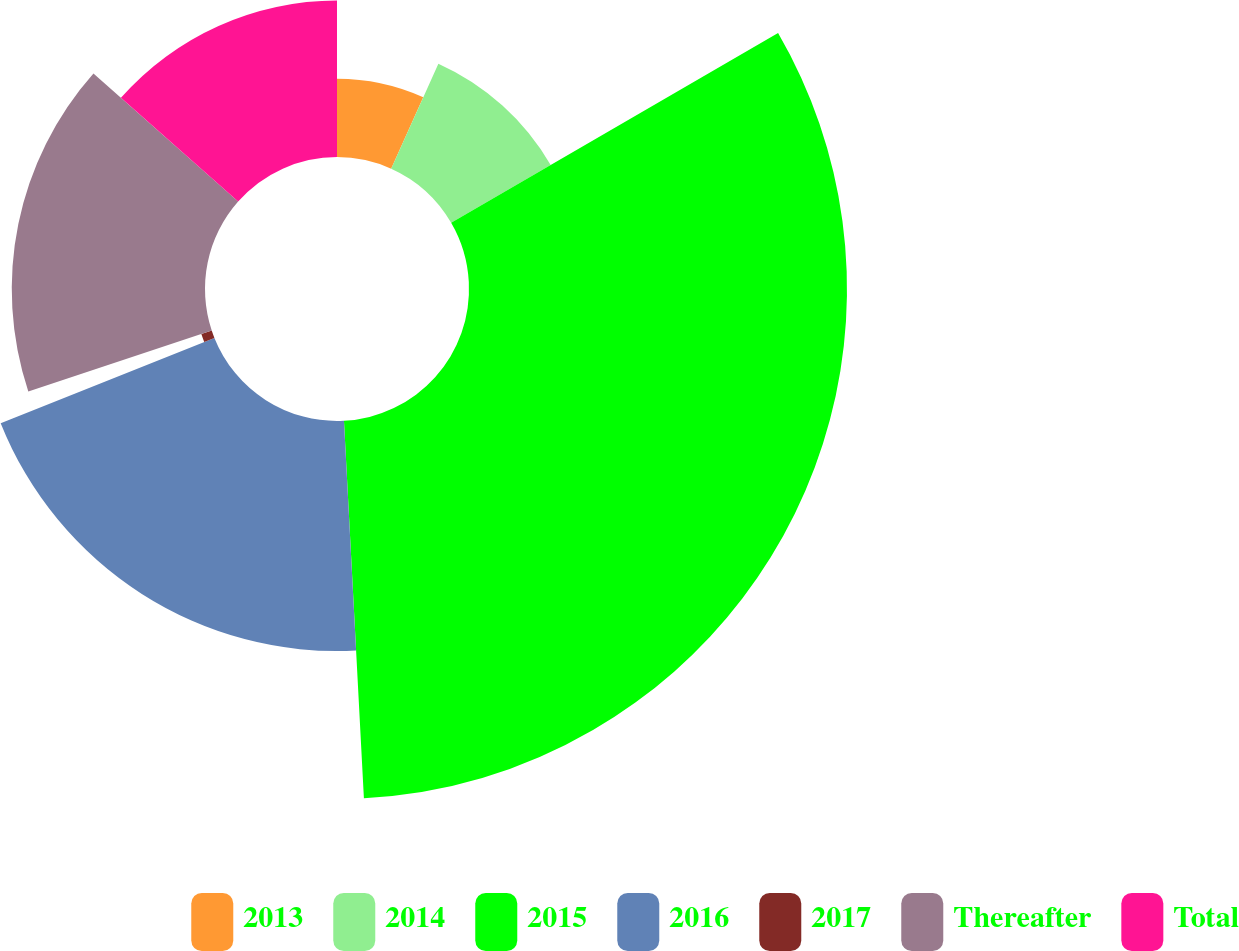Convert chart to OTSL. <chart><loc_0><loc_0><loc_500><loc_500><pie_chart><fcel>2013<fcel>2014<fcel>2015<fcel>2016<fcel>2017<fcel>Thereafter<fcel>Total<nl><fcel>6.73%<fcel>9.9%<fcel>32.53%<fcel>19.8%<fcel>0.94%<fcel>16.63%<fcel>13.47%<nl></chart> 